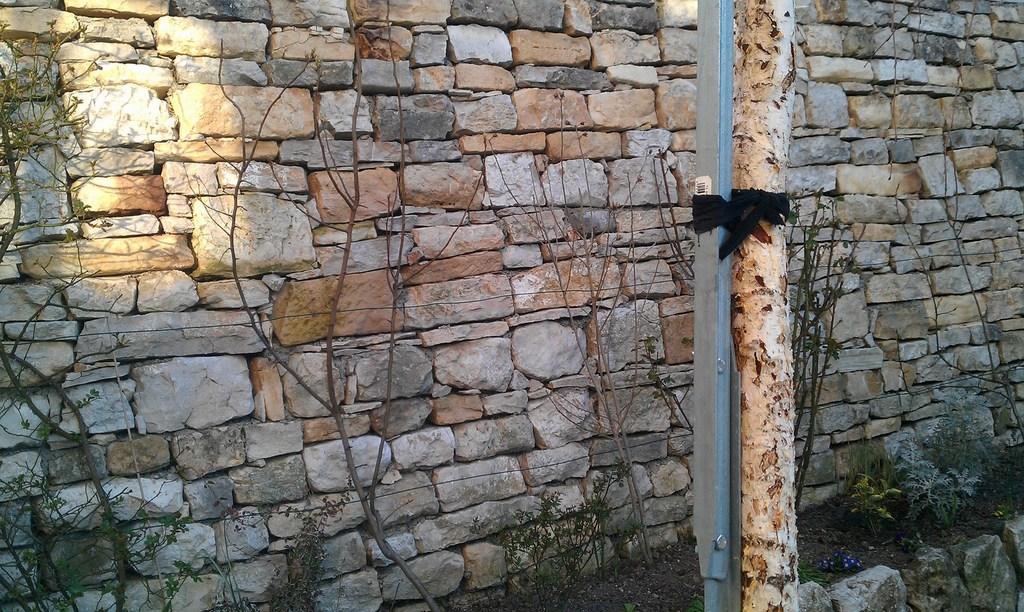Please provide a concise description of this image. In this image we can see a wall built with stones. We can also see some plants, red stems and a bark of a tree tied to a pole with a ribbon. 